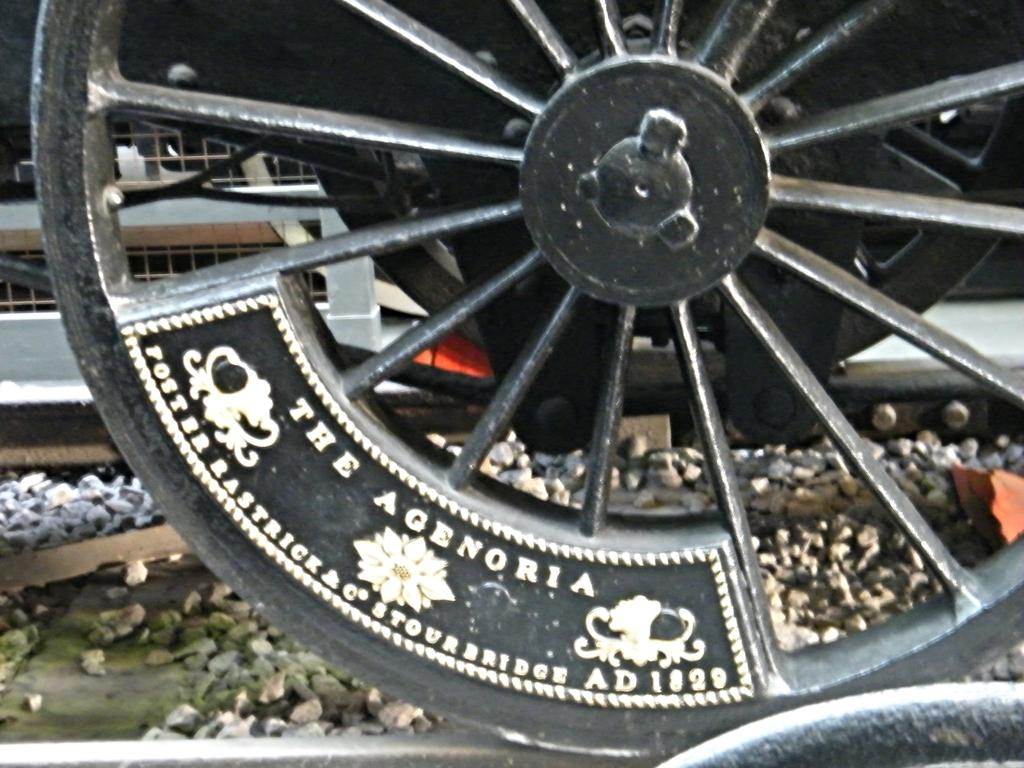<image>
Summarize the visual content of the image. An old metal wheel with the words The Agenoria stamped on it. 